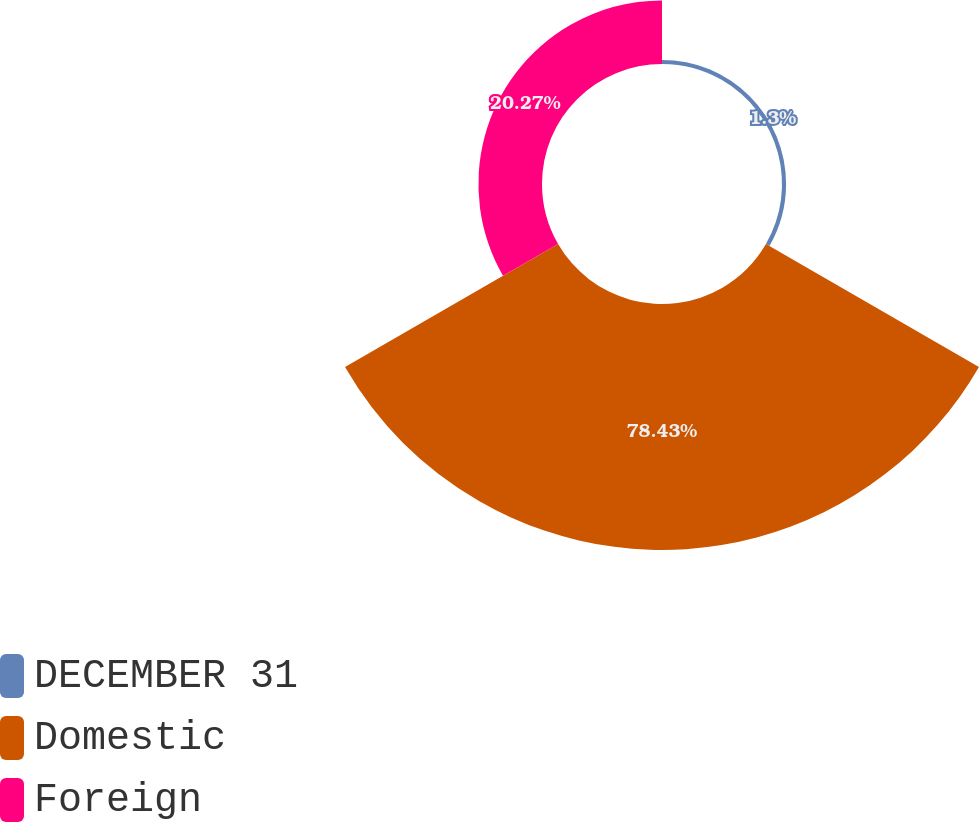Convert chart to OTSL. <chart><loc_0><loc_0><loc_500><loc_500><pie_chart><fcel>DECEMBER 31<fcel>Domestic<fcel>Foreign<nl><fcel>1.3%<fcel>78.43%<fcel>20.27%<nl></chart> 